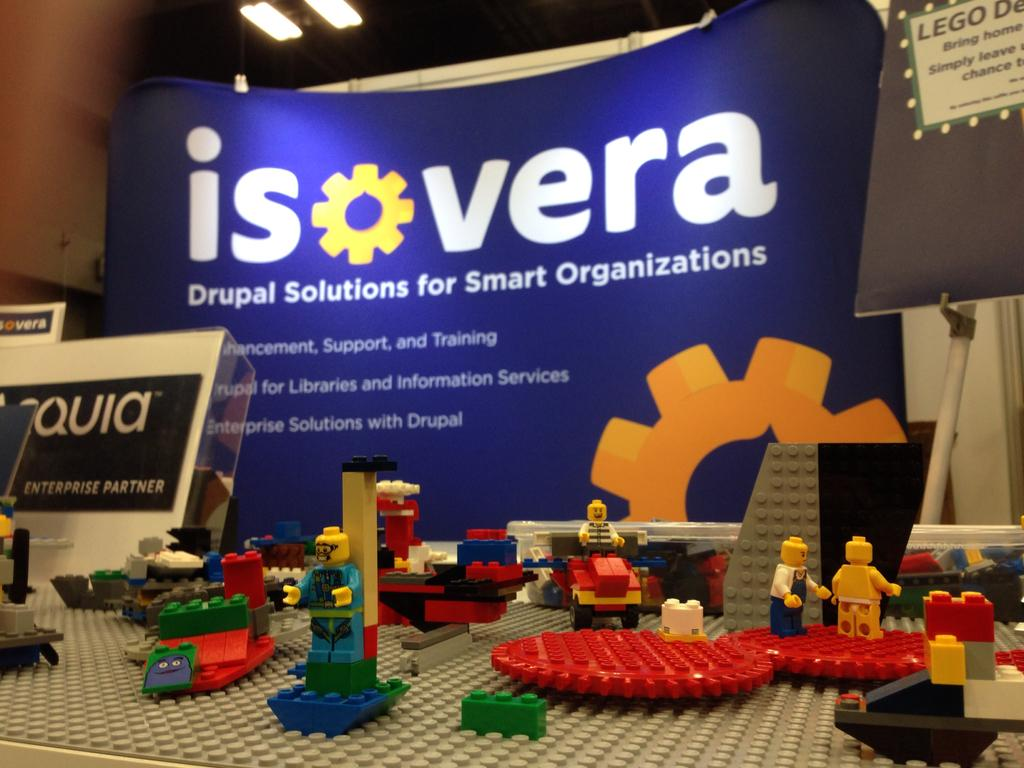What objects can be seen in the image? There are toys in the image. What can be seen in the background of the image? There is a hoarding in the background of the image. Where is the board located in the image? The board is on the right side of the image. What is visible at the top of the image? Lights are visible at the top of the image. What type of beef is being cooked in the image? There is no beef present in the image; it features toys, a hoarding, a board, and lights. Can you see a sock hanging from the board in the image? There is no sock visible in the image. 